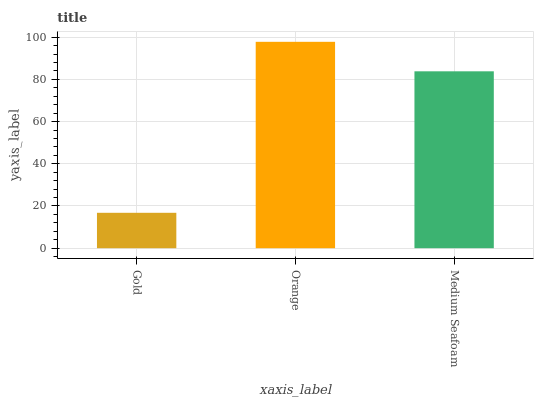Is Gold the minimum?
Answer yes or no. Yes. Is Orange the maximum?
Answer yes or no. Yes. Is Medium Seafoam the minimum?
Answer yes or no. No. Is Medium Seafoam the maximum?
Answer yes or no. No. Is Orange greater than Medium Seafoam?
Answer yes or no. Yes. Is Medium Seafoam less than Orange?
Answer yes or no. Yes. Is Medium Seafoam greater than Orange?
Answer yes or no. No. Is Orange less than Medium Seafoam?
Answer yes or no. No. Is Medium Seafoam the high median?
Answer yes or no. Yes. Is Medium Seafoam the low median?
Answer yes or no. Yes. Is Gold the high median?
Answer yes or no. No. Is Gold the low median?
Answer yes or no. No. 